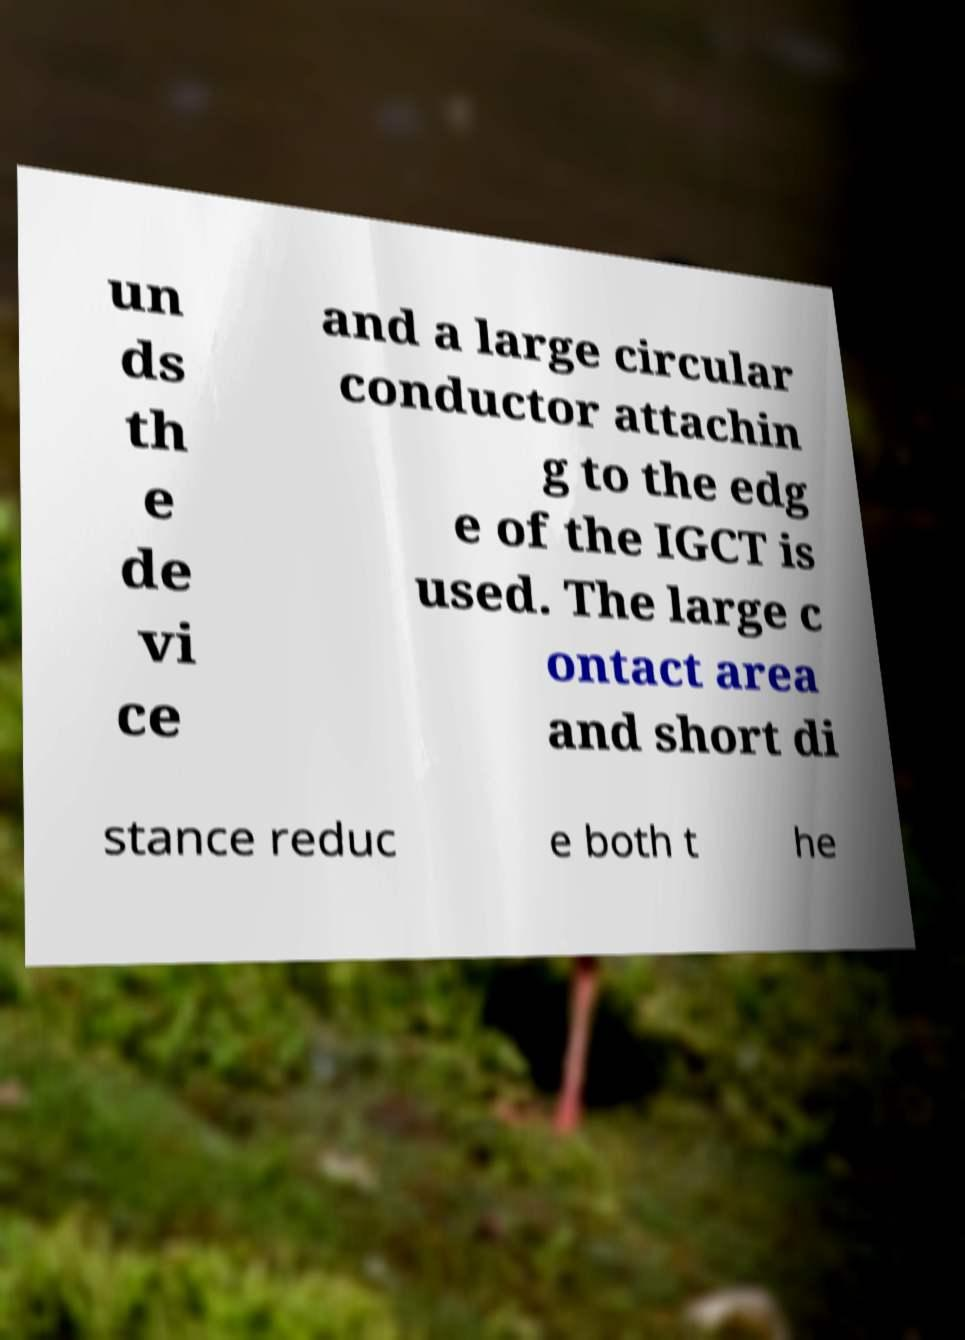Could you extract and type out the text from this image? un ds th e de vi ce and a large circular conductor attachin g to the edg e of the IGCT is used. The large c ontact area and short di stance reduc e both t he 